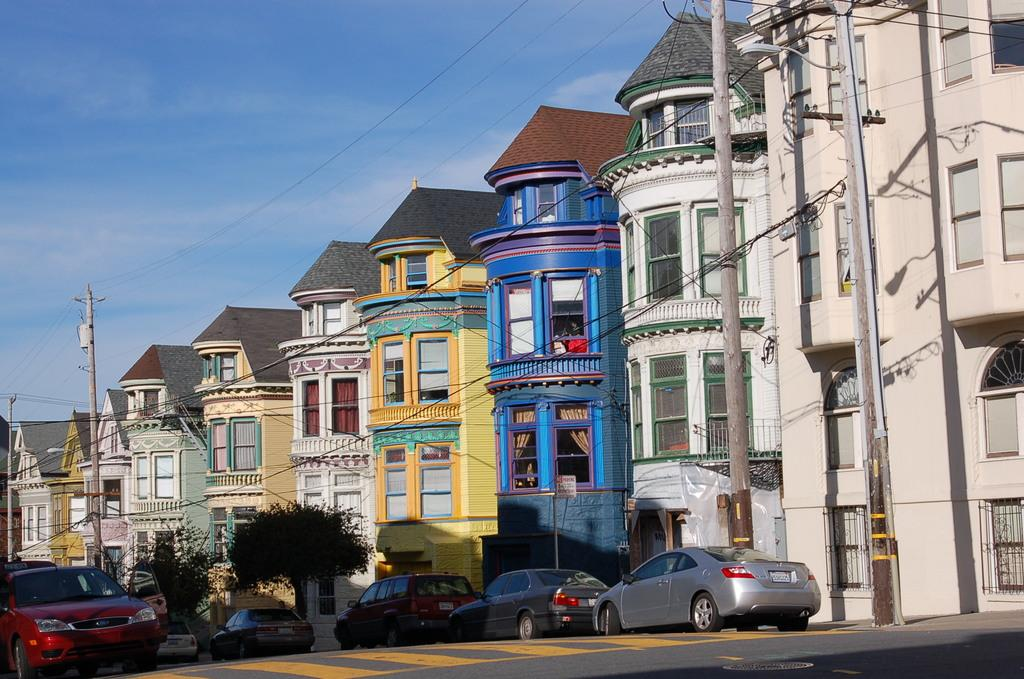What type of structures are visible in the image? There are buildings with windows in the image. What other natural elements can be seen in the image? There are trees in the image. Are there any vehicles visible in the image? Yes, there are cars in the image. What is visible in the background of the image? The sky is visible in the image. Can you tell me how many frogs are sitting on the roof of the building in the image? There are no frogs present in the image; it features buildings, trees, cars, and the sky. What type of grain is being harvested in the image? There is no grain being harvested in the image; it focuses on buildings, trees, cars, and the sky. 